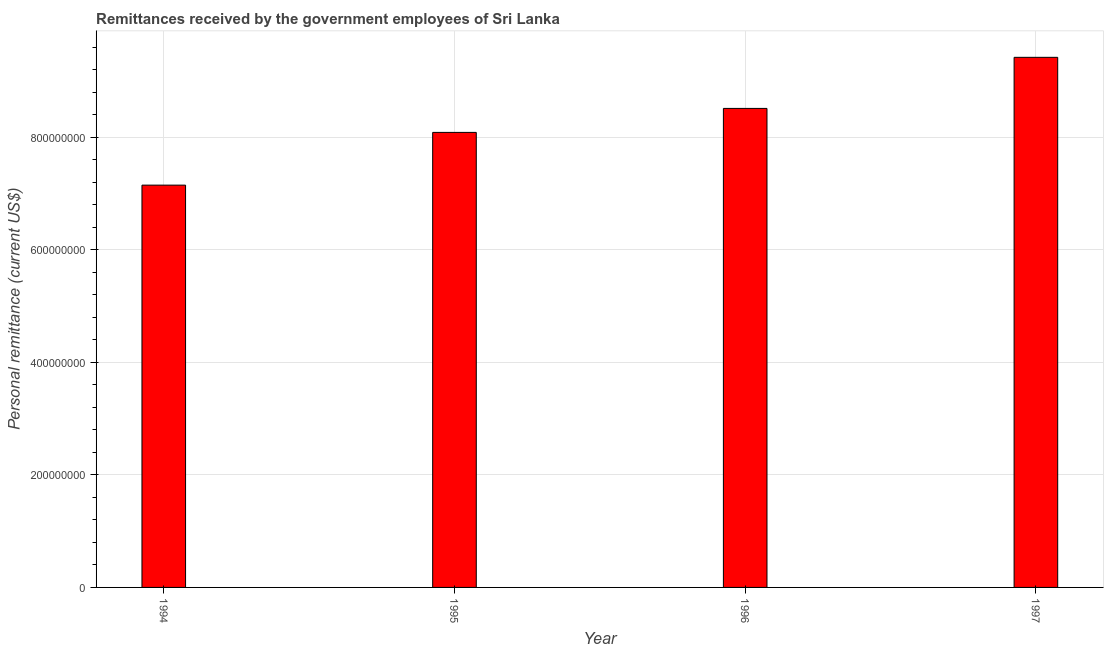Does the graph contain any zero values?
Offer a terse response. No. Does the graph contain grids?
Keep it short and to the point. Yes. What is the title of the graph?
Give a very brief answer. Remittances received by the government employees of Sri Lanka. What is the label or title of the X-axis?
Keep it short and to the point. Year. What is the label or title of the Y-axis?
Make the answer very short. Personal remittance (current US$). What is the personal remittances in 1994?
Make the answer very short. 7.15e+08. Across all years, what is the maximum personal remittances?
Provide a short and direct response. 9.42e+08. Across all years, what is the minimum personal remittances?
Ensure brevity in your answer.  7.15e+08. In which year was the personal remittances minimum?
Offer a very short reply. 1994. What is the sum of the personal remittances?
Provide a succinct answer. 3.32e+09. What is the difference between the personal remittances in 1994 and 1997?
Provide a short and direct response. -2.27e+08. What is the average personal remittances per year?
Offer a very short reply. 8.30e+08. What is the median personal remittances?
Give a very brief answer. 8.30e+08. In how many years, is the personal remittances greater than 360000000 US$?
Ensure brevity in your answer.  4. What is the ratio of the personal remittances in 1994 to that in 1996?
Give a very brief answer. 0.84. Is the difference between the personal remittances in 1995 and 1996 greater than the difference between any two years?
Offer a very short reply. No. What is the difference between the highest and the second highest personal remittances?
Give a very brief answer. 9.08e+07. What is the difference between the highest and the lowest personal remittances?
Your answer should be compact. 2.27e+08. Are all the bars in the graph horizontal?
Keep it short and to the point. No. What is the difference between two consecutive major ticks on the Y-axis?
Your response must be concise. 2.00e+08. Are the values on the major ticks of Y-axis written in scientific E-notation?
Keep it short and to the point. No. What is the Personal remittance (current US$) in 1994?
Make the answer very short. 7.15e+08. What is the Personal remittance (current US$) in 1995?
Give a very brief answer. 8.09e+08. What is the Personal remittance (current US$) of 1996?
Give a very brief answer. 8.52e+08. What is the Personal remittance (current US$) of 1997?
Make the answer very short. 9.42e+08. What is the difference between the Personal remittance (current US$) in 1994 and 1995?
Your answer should be compact. -9.38e+07. What is the difference between the Personal remittance (current US$) in 1994 and 1996?
Make the answer very short. -1.36e+08. What is the difference between the Personal remittance (current US$) in 1994 and 1997?
Keep it short and to the point. -2.27e+08. What is the difference between the Personal remittance (current US$) in 1995 and 1996?
Ensure brevity in your answer.  -4.26e+07. What is the difference between the Personal remittance (current US$) in 1995 and 1997?
Offer a very short reply. -1.33e+08. What is the difference between the Personal remittance (current US$) in 1996 and 1997?
Provide a short and direct response. -9.08e+07. What is the ratio of the Personal remittance (current US$) in 1994 to that in 1995?
Provide a succinct answer. 0.88. What is the ratio of the Personal remittance (current US$) in 1994 to that in 1996?
Your response must be concise. 0.84. What is the ratio of the Personal remittance (current US$) in 1994 to that in 1997?
Offer a terse response. 0.76. What is the ratio of the Personal remittance (current US$) in 1995 to that in 1996?
Offer a terse response. 0.95. What is the ratio of the Personal remittance (current US$) in 1995 to that in 1997?
Your answer should be very brief. 0.86. What is the ratio of the Personal remittance (current US$) in 1996 to that in 1997?
Give a very brief answer. 0.9. 